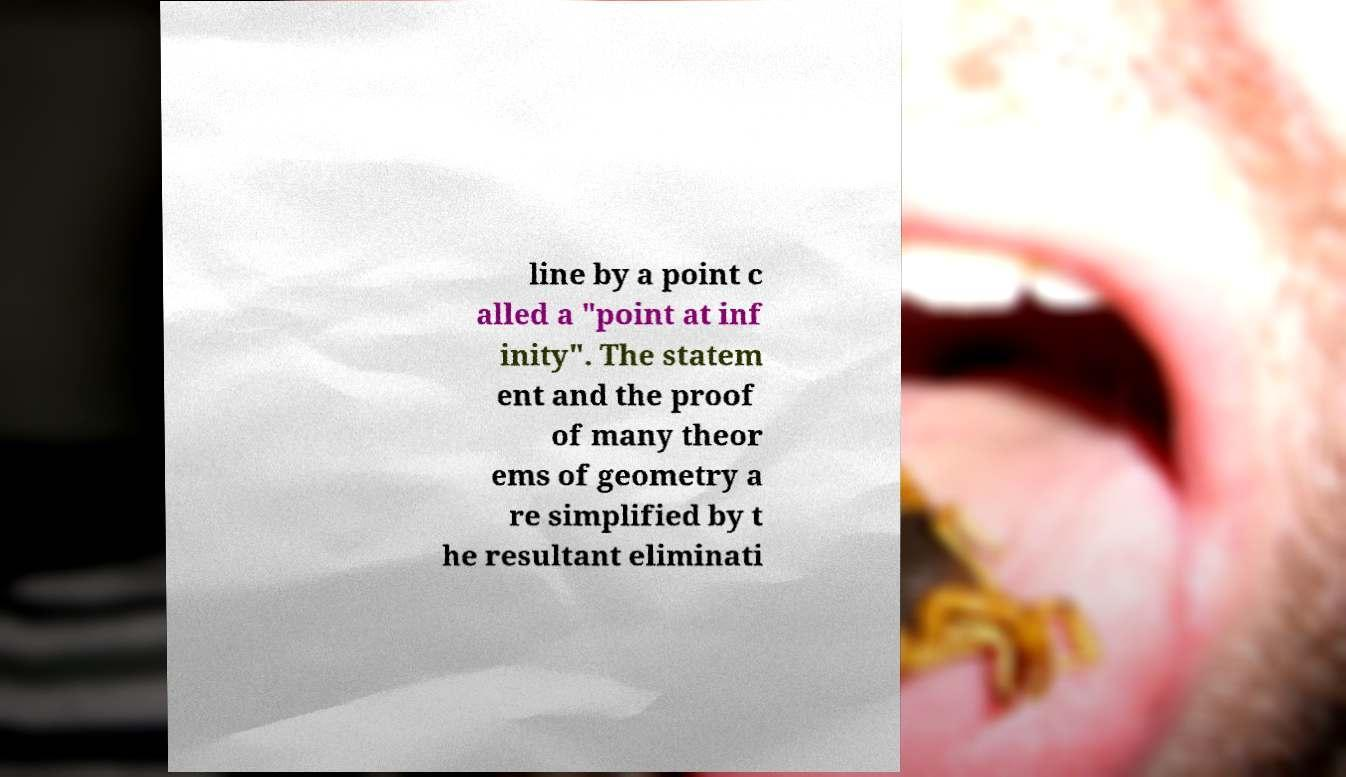Can you accurately transcribe the text from the provided image for me? line by a point c alled a "point at inf inity". The statem ent and the proof of many theor ems of geometry a re simplified by t he resultant eliminati 